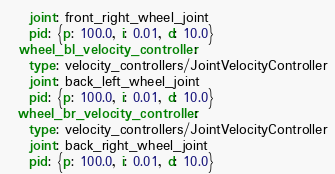Convert code to text. <code><loc_0><loc_0><loc_500><loc_500><_YAML_>    joint: front_right_wheel_joint
    pid: {p: 100.0, i: 0.01, d: 10.0}
  wheel_bl_velocity_controller:
    type: velocity_controllers/JointVelocityController
    joint: back_left_wheel_joint
    pid: {p: 100.0, i: 0.01, d: 10.0}
  wheel_br_velocity_controller:
    type: velocity_controllers/JointVelocityController
    joint: back_right_wheel_joint
    pid: {p: 100.0, i: 0.01, d: 10.0}
</code> 